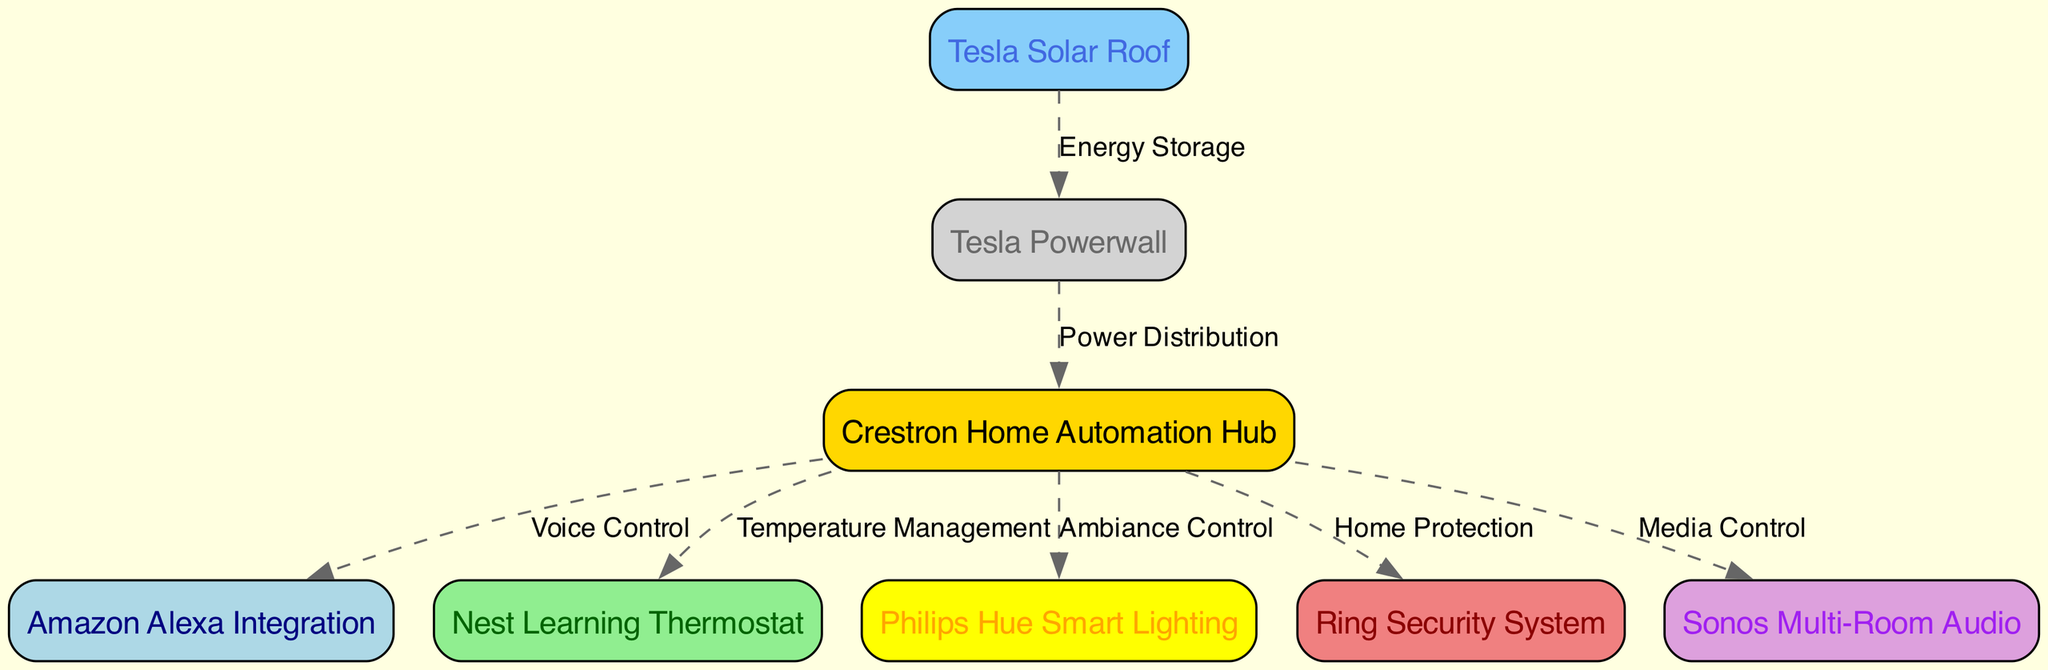What is the main control unit of the system? The diagram identifies the "Crestron Home Automation Hub" as the central hub, which coordinates all other components and functionalities.
Answer: Crestron Home Automation Hub How many nodes are there in the diagram? By counting the listed nodes, there are eight components represented, including the central hub, voice assistant, climate control, lighting, security, entertainment, solar panels, and battery.
Answer: Eight Which feature is connected to the security system? Following the diagram paths shows that the "Ring Security System" is linked directly to the "Crestron Home Automation Hub" for home protection.
Answer: Home Protection What type of thermostat is used for climate control? The diagram clearly states that a "Nest Learning Thermostat" is the specified device for climate management within the smart home system.
Answer: Nest Learning Thermostat How does the battery interact with the system? The "Tesla Powerwall" receives energy storage from "Tesla Solar Roof" and subsequently distributes power to the "Crestron Home Automation Hub," ensuring reliable energy supply for the home.
Answer: Power Distribution What is the purpose of the voice assistant integration? According to the schematic, the "Amazon Alexa Integration" allows for voice control functionality, making it easier to interact and manage the entire home automation system using voice commands.
Answer: Voice Control Which component provides energy storage for the system? The diagram indicates that the "Tesla Powerwall" acts as the energy storage system, linked directly to the solar panels for efficient energy use.
Answer: Tesla Powerwall How are the solar panels connected to the battery? The "Tesla Solar Roof" is directly linked to the "Tesla Powerwall," indicating a flow of energy where the solar panels supply energy that is stored in the battery for later use.
Answer: Energy Storage What type of lighting is used in the system? The schematic specifically mentions "Philips Hue Smart Lighting," outlining that this particular brand and type is implemented for ambiance control within the home.
Answer: Philips Hue Smart Lighting 